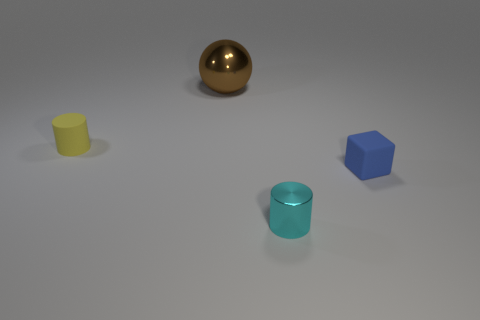Add 3 tiny cyan metallic cylinders. How many objects exist? 7 Subtract all balls. How many objects are left? 3 Subtract 1 yellow cylinders. How many objects are left? 3 Subtract all tiny red things. Subtract all blue cubes. How many objects are left? 3 Add 3 tiny yellow things. How many tiny yellow things are left? 4 Add 1 green objects. How many green objects exist? 1 